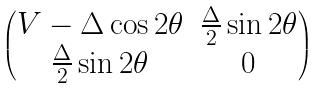Convert formula to latex. <formula><loc_0><loc_0><loc_500><loc_500>\begin{pmatrix} V - \Delta \cos 2 \theta & \frac { \Delta } { 2 } \sin 2 \theta \\ \frac { \Delta } { 2 } \sin 2 \theta & 0 \\ \end{pmatrix}</formula> 